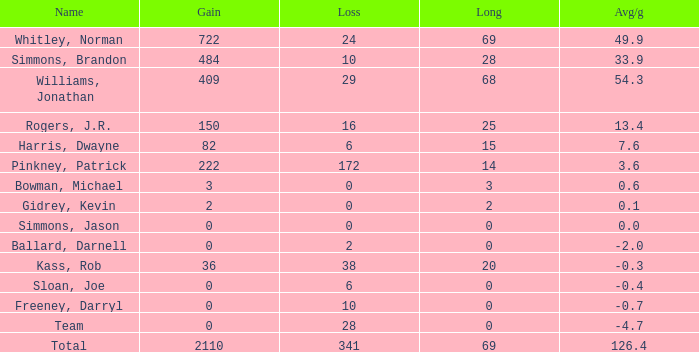What is the highest Loss, when Long is greater than 0, when Gain is greater than 484, and when Avg/g is greater than 126.4? None. 